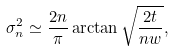Convert formula to latex. <formula><loc_0><loc_0><loc_500><loc_500>\sigma _ { n } ^ { 2 } \simeq \frac { 2 n } { \pi } \arctan \sqrt { \frac { 2 t } { n w } } ,</formula> 